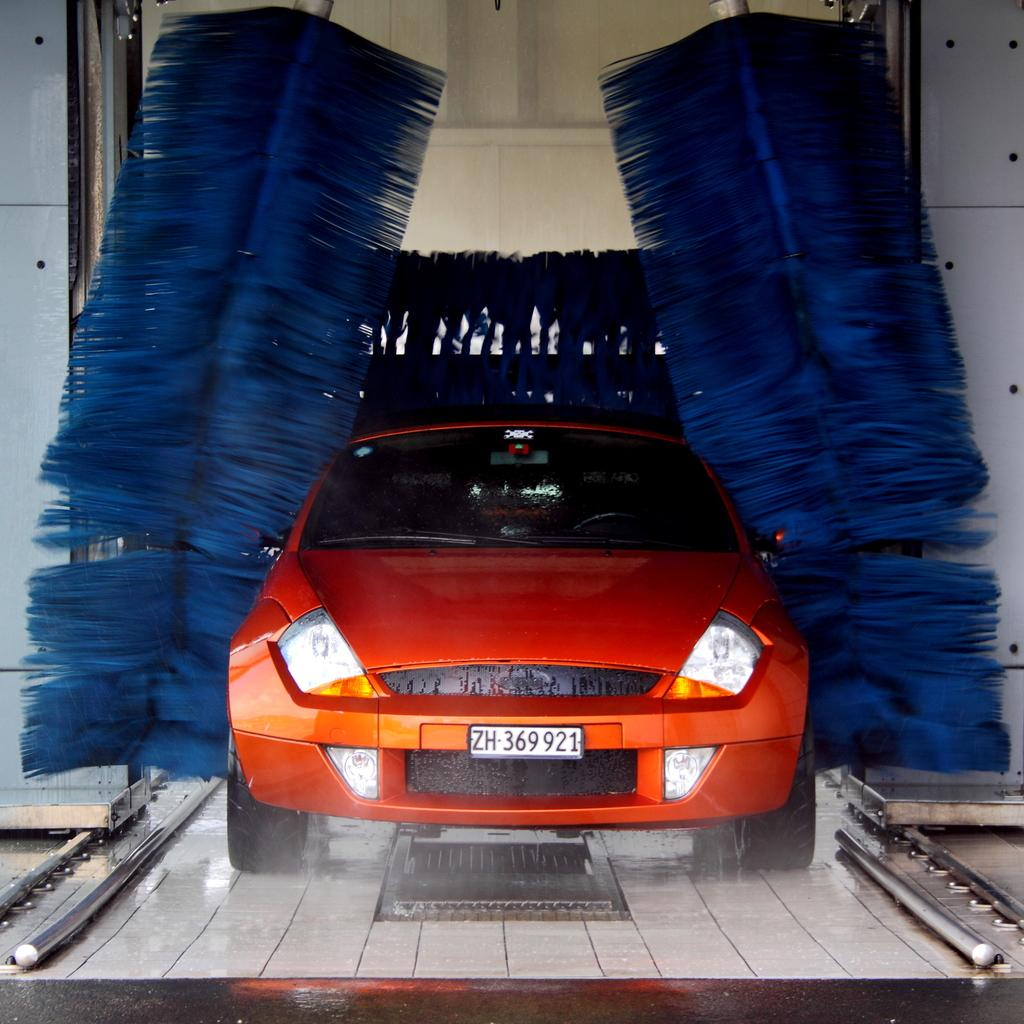What type of vehicle is in the image? The vehicle in the image resembles a model of quills. Can you describe the background of the image? There is a wall in the background of the image. What type of request is being made by the coach in the image? There is no coach present in the image, and therefore no such request can be observed. 